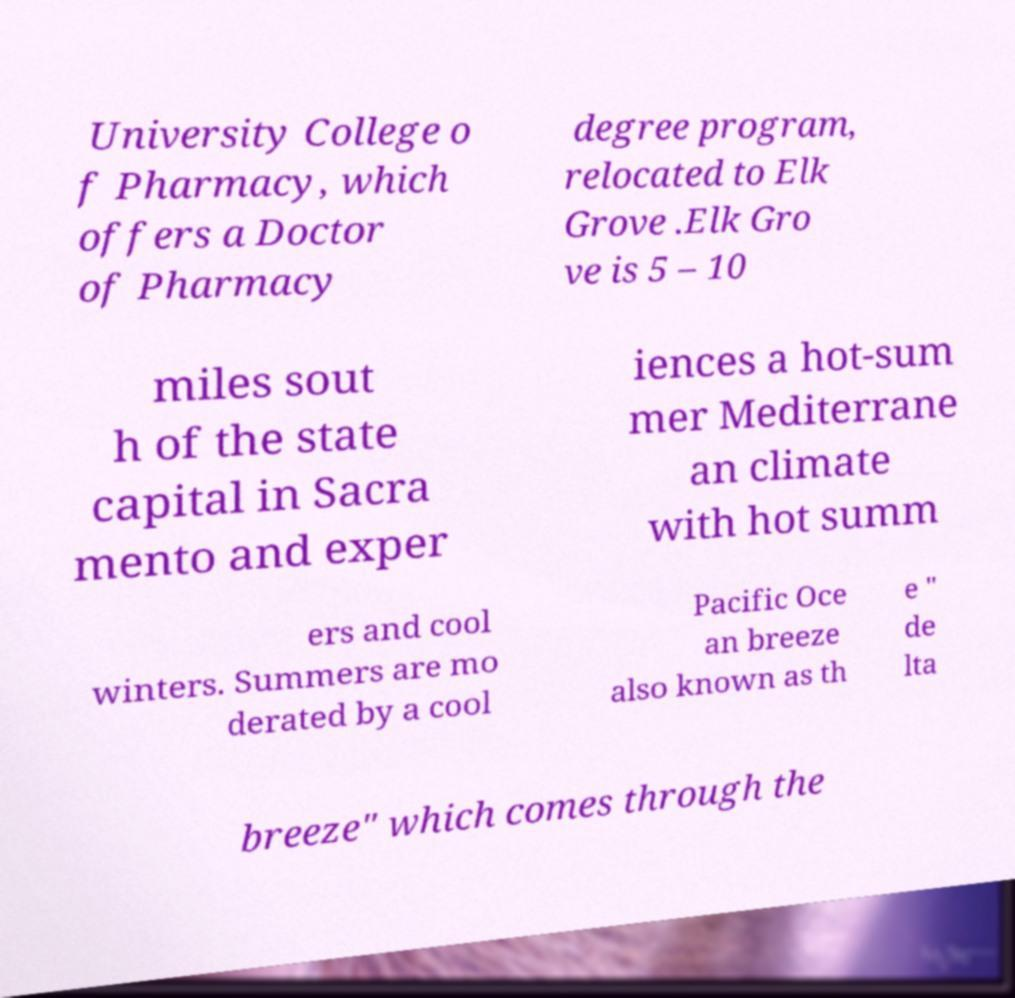What messages or text are displayed in this image? I need them in a readable, typed format. University College o f Pharmacy, which offers a Doctor of Pharmacy degree program, relocated to Elk Grove .Elk Gro ve is 5 – 10 miles sout h of the state capital in Sacra mento and exper iences a hot-sum mer Mediterrane an climate with hot summ ers and cool winters. Summers are mo derated by a cool Pacific Oce an breeze also known as th e " de lta breeze" which comes through the 